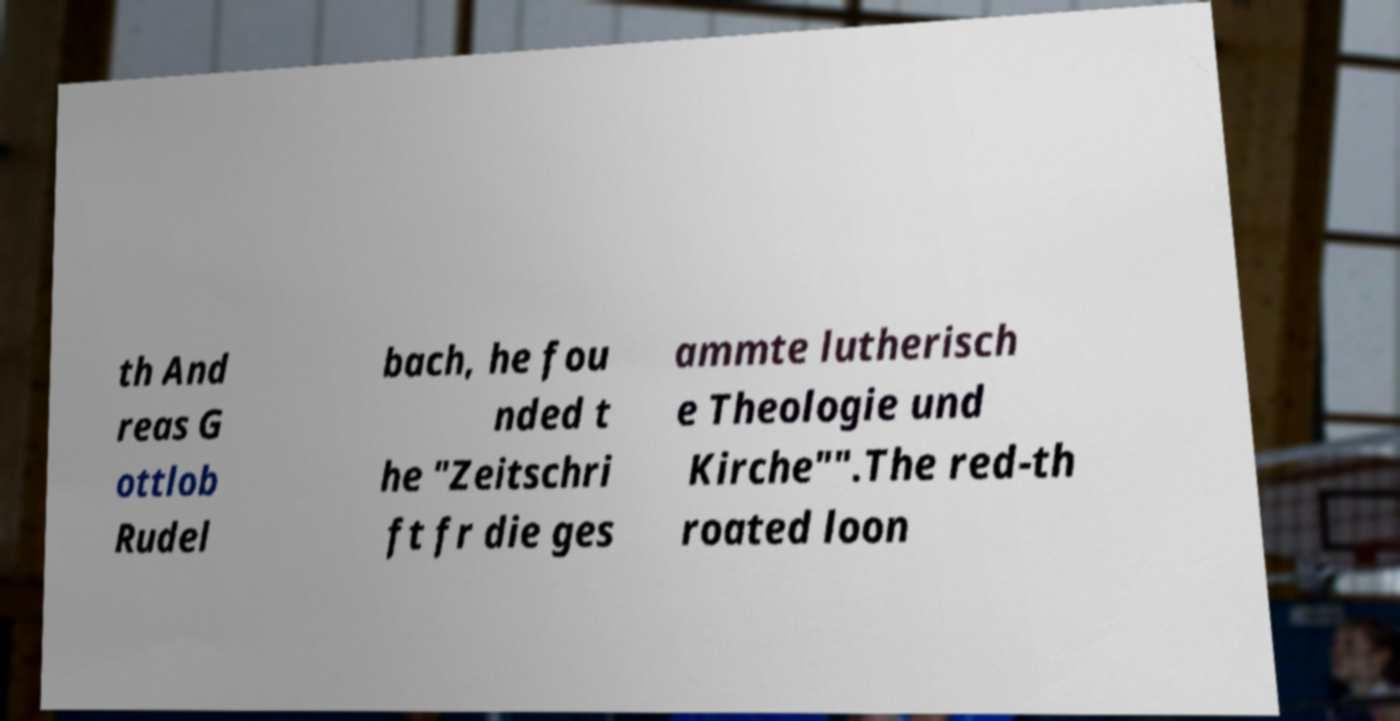Please read and relay the text visible in this image. What does it say? th And reas G ottlob Rudel bach, he fou nded t he "Zeitschri ft fr die ges ammte lutherisch e Theologie und Kirche"".The red-th roated loon 